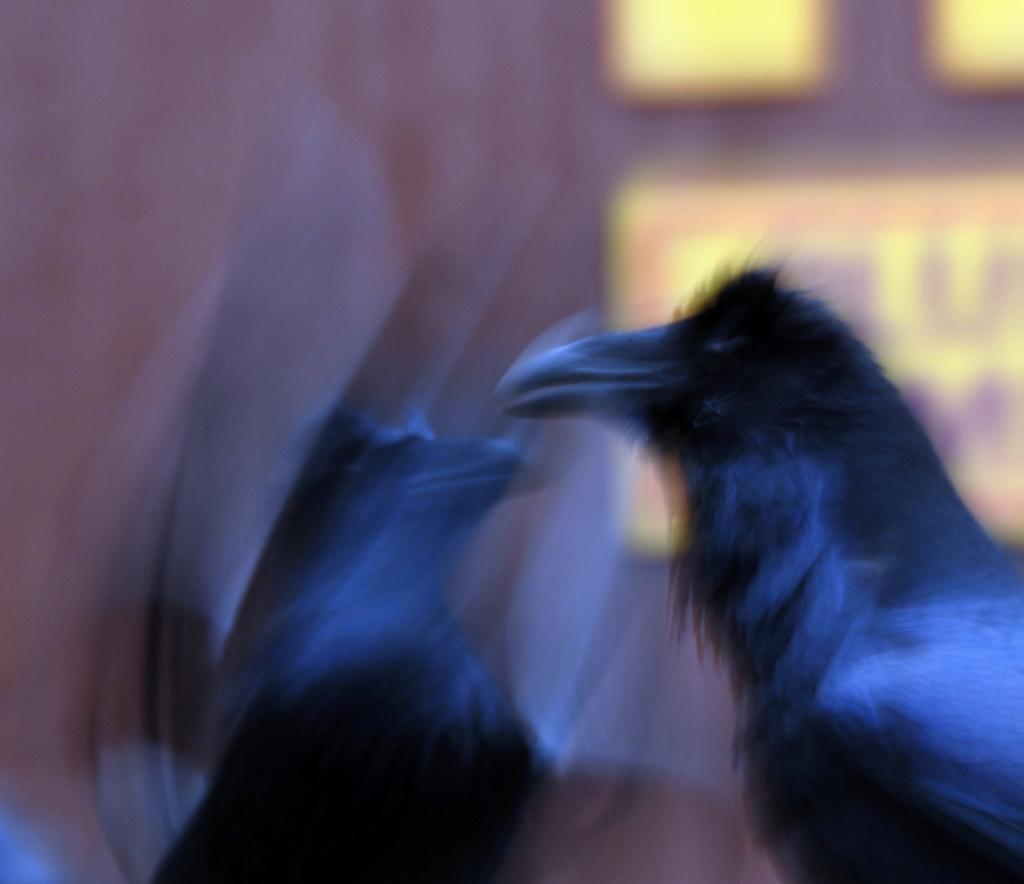Describe this image in one or two sentences. There is a blur image and here we can see two birds. 